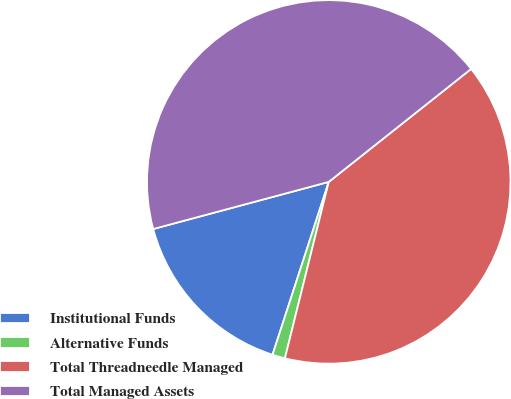<chart> <loc_0><loc_0><loc_500><loc_500><pie_chart><fcel>Institutional Funds<fcel>Alternative Funds<fcel>Total Threadneedle Managed<fcel>Total Managed Assets<nl><fcel>15.82%<fcel>1.13%<fcel>39.55%<fcel>43.5%<nl></chart> 